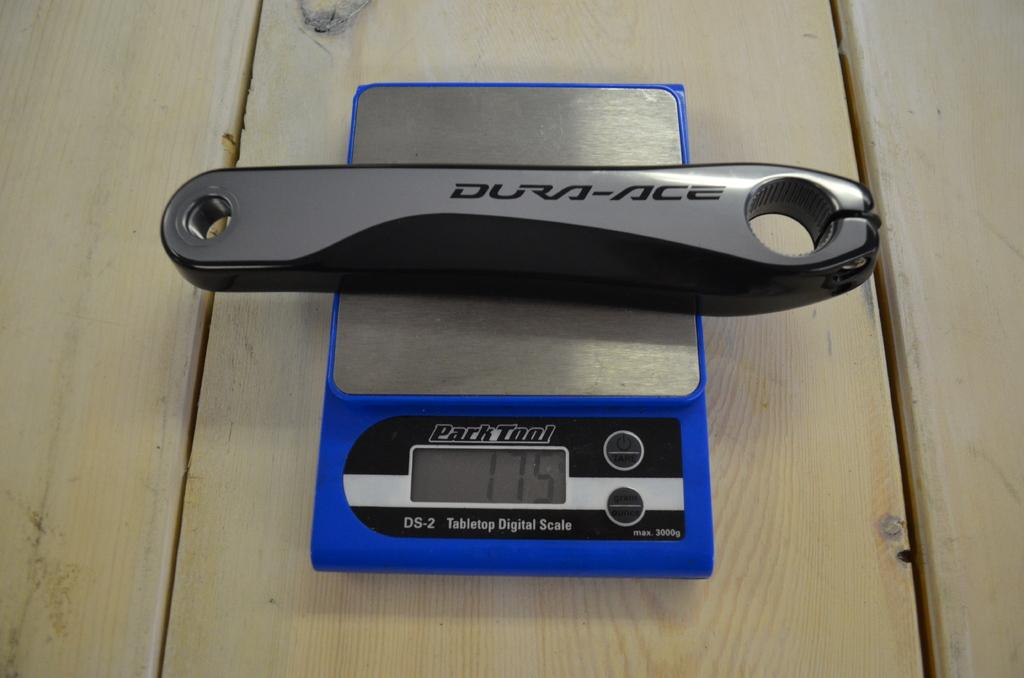What type of equipment is visible in the image? There is a weight machine in the image. What is the weight machine placed on? The weight machine is on a wooden object, likely a table. What is on top of the weight machine? There is an object on the weight machine. What type of story is being told by the weight machine in the image? There is no story being told by the weight machine in the image; it is a piece of exercise equipment. 